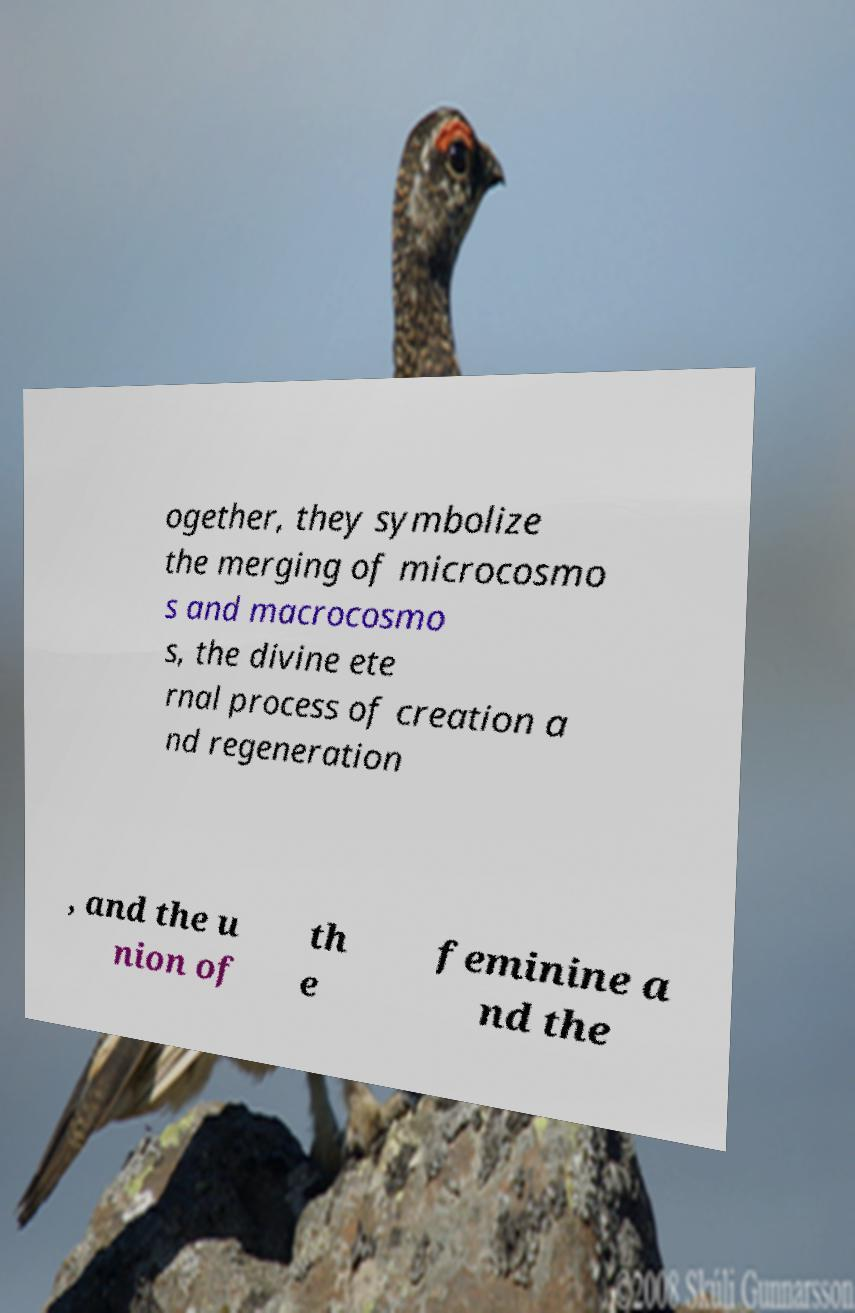Please read and relay the text visible in this image. What does it say? ogether, they symbolize the merging of microcosmo s and macrocosmo s, the divine ete rnal process of creation a nd regeneration , and the u nion of th e feminine a nd the 